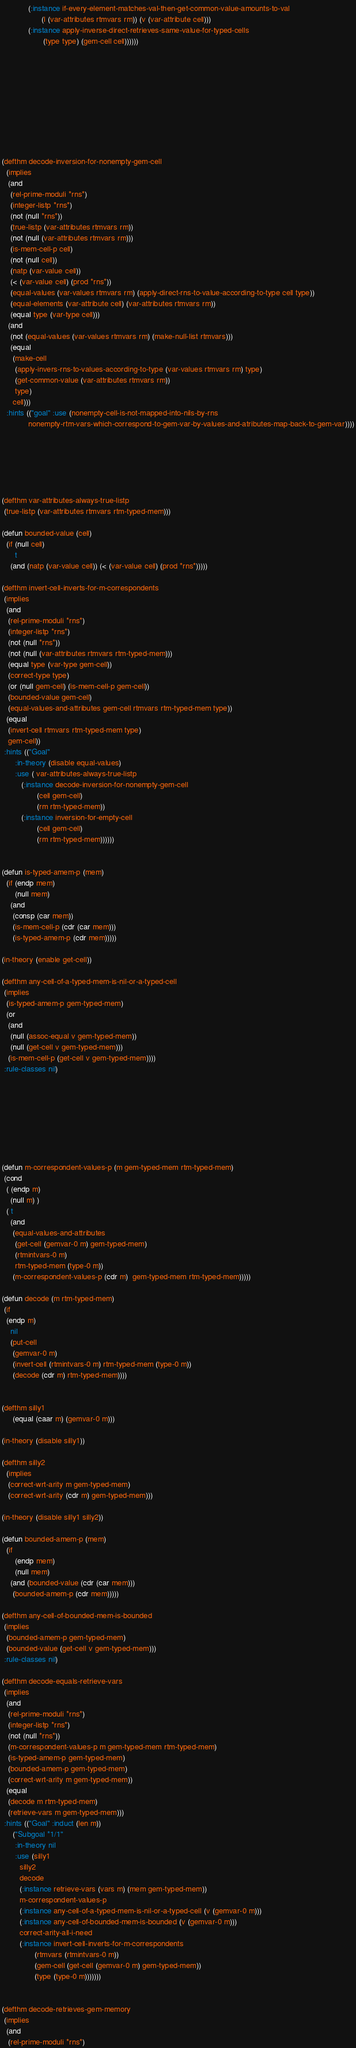Convert code to text. <code><loc_0><loc_0><loc_500><loc_500><_Lisp_>			(:instance if-every-element-matches-val-then-get-common-value-amounts-to-val
				  (l (var-attributes rtmvars rm)) (v (var-attribute cell)))
			(:instance apply-inverse-direct-retrieves-same-value-for-typed-cells
				   (type type) (gem-cell cell))))))




	





(defthm decode-inversion-for-nonempty-gem-cell
  (implies
   (and
    (rel-prime-moduli *rns*)
    (integer-listp *rns*)
    (not (null *rns*))
    (true-listp (var-attributes rtmvars rm)) 
    (not (null (var-attributes rtmvars rm)))  
    (is-mem-cell-p cell)
    (not (null cell))
    (natp (var-value cell))
    (< (var-value cell) (prod *rns*))
    (equal-values (var-values rtmvars rm) (apply-direct-rns-to-value-according-to-type cell type))
    (equal-elements (var-attribute cell) (var-attributes rtmvars rm)) 
    (equal type (var-type cell)))
   (and
    (not (equal-values (var-values rtmvars rm) (make-null-list rtmvars)))
    (equal 
     (make-cell
      (apply-invers-rns-to-values-according-to-type (var-values rtmvars rm) type)
      (get-common-value (var-attributes rtmvars rm))
      type)
     cell)))
  :hints (("goal" :use (nonempty-cell-is-not-mapped-into-nils-by-rns 
			nonempty-rtm-vars-which-correspond-to-gem-var-by-values-and-atributes-map-back-to-gem-var))))






(defthm var-attributes-always-true-listp
 (true-listp (var-attributes rtmvars rtm-typed-mem)))

(defun bounded-value (cell)
  (if (null cell) 
      t
    (and (natp (var-value cell)) (< (var-value cell) (prod *rns*)))))

(defthm invert-cell-inverts-for-m-correspondents
 (implies
  (and
   (rel-prime-moduli *rns*)
   (integer-listp *rns*)
   (not (null *rns*))
   (not (null (var-attributes rtmvars rtm-typed-mem)))
   (equal type (var-type gem-cell))
   (correct-type type)
   (or (null gem-cell) (is-mem-cell-p gem-cell))
   (bounded-value gem-cell)
   (equal-values-and-attributes gem-cell rtmvars rtm-typed-mem type))
  (equal 
   (invert-cell rtmvars rtm-typed-mem type)
   gem-cell))
 :hints (("Goal" 
	  :in-theory (disable equal-values)
	  :use ( var-attributes-always-true-listp
		 (:instance decode-inversion-for-nonempty-gem-cell 
			    (cell gem-cell)
			    (rm rtm-typed-mem))
		 (:instance inversion-for-empty-cell 
			    (cell gem-cell)
			    (rm rtm-typed-mem))))))


(defun is-typed-amem-p (mem)
  (if (endp mem)
      (null mem)
    (and
     (consp (car mem))
     (is-mem-cell-p (cdr (car mem)))
     (is-typed-amem-p (cdr mem)))))

(in-theory (enable get-cell))

(defthm any-cell-of-a-typed-mem-is-nil-or-a-typed-cell
 (implies
  (is-typed-amem-p gem-typed-mem)
  (or
   (and
    (null (assoc-equal v gem-typed-mem))
    (null (get-cell v gem-typed-mem)))
   (is-mem-cell-p (get-cell v gem-typed-mem))))
 :rule-classes nil)








(defun m-correspondent-values-p (m gem-typed-mem rtm-typed-mem)
 (cond
  ( (endp m)
    (null m) )
  ( t
    (and
     (equal-values-and-attributes 
      (get-cell (gemvar-0 m) gem-typed-mem) 
      (rtmintvars-0 m) 
      rtm-typed-mem (type-0 m))
     (m-correspondent-values-p (cdr m)  gem-typed-mem rtm-typed-mem)))))
 
(defun decode (m rtm-typed-mem)
 (if
  (endp m)
    nil 
    (put-cell
     (gemvar-0 m)
     (invert-cell (rtmintvars-0 m) rtm-typed-mem (type-0 m))
     (decode (cdr m) rtm-typed-mem))))


(defthm silly1 
     (equal (caar m) (gemvar-0 m)))

(in-theory (disable silly1))

(defthm silly2
  (implies
   (correct-wrt-arity m gem-typed-mem)
   (correct-wrt-arity (cdr m) gem-typed-mem)))

(in-theory (disable silly1 silly2))

(defun bounded-amem-p (mem)
  (if
      (endp mem)
      (null mem)
    (and (bounded-value (cdr (car mem)))
	 (bounded-amem-p (cdr mem)))))
   
(defthm any-cell-of-bounded-mem-is-bounded
 (implies
  (bounded-amem-p gem-typed-mem)
  (bounded-value (get-cell v gem-typed-mem)))
 :rule-classes nil)

(defthm decode-equals-retrieve-vars
 (implies
  (and
   (rel-prime-moduli *rns*)
   (integer-listp *rns*)
   (not (null *rns*))
   (m-correspondent-values-p m gem-typed-mem rtm-typed-mem)
   (is-typed-amem-p gem-typed-mem)
   (bounded-amem-p gem-typed-mem)
   (correct-wrt-arity m gem-typed-mem))
  (equal
   (decode m rtm-typed-mem)
   (retrieve-vars m gem-typed-mem)))
 :hints (("Goal" :induct (len m))
	 ("Subgoal *1/1"
	  :in-theory nil 
	  :use (silly1
		silly2
		decode
		(:instance retrieve-vars (vars m) (mem gem-typed-mem))
		m-correspondent-values-p
		(:instance any-cell-of-a-typed-mem-is-nil-or-a-typed-cell (v (gemvar-0 m)))
		(:instance any-cell-of-bounded-mem-is-bounded (v (gemvar-0 m)))
		correct-arity-all-i-need
		(:instance invert-cell-inverts-for-m-correspondents
			   (rtmvars (rtmintvars-0 m))
			   (gem-cell (get-cell (gemvar-0 m) gem-typed-mem))
			   (type (type-0 m)))))))


(defthm decode-retrieves-gem-memory
 (implies
  (and
   (rel-prime-moduli *rns*)</code> 